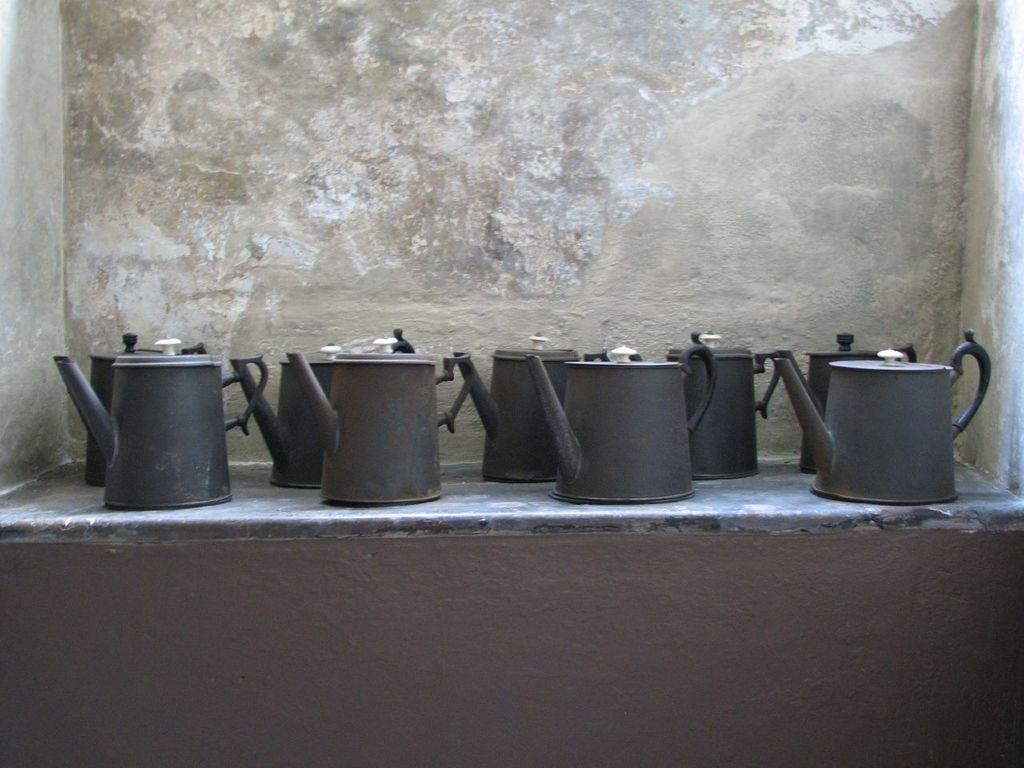Can you describe this image briefly? In this picture we can see a group of kettles on a platform and in the background we can see wall. 